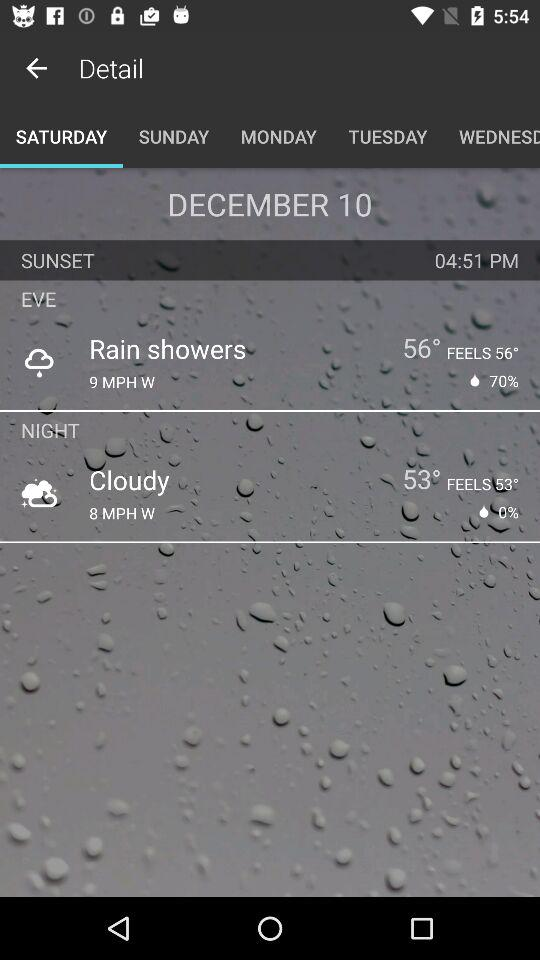What is the temperature for the night?
Answer the question using a single word or phrase. 53° 